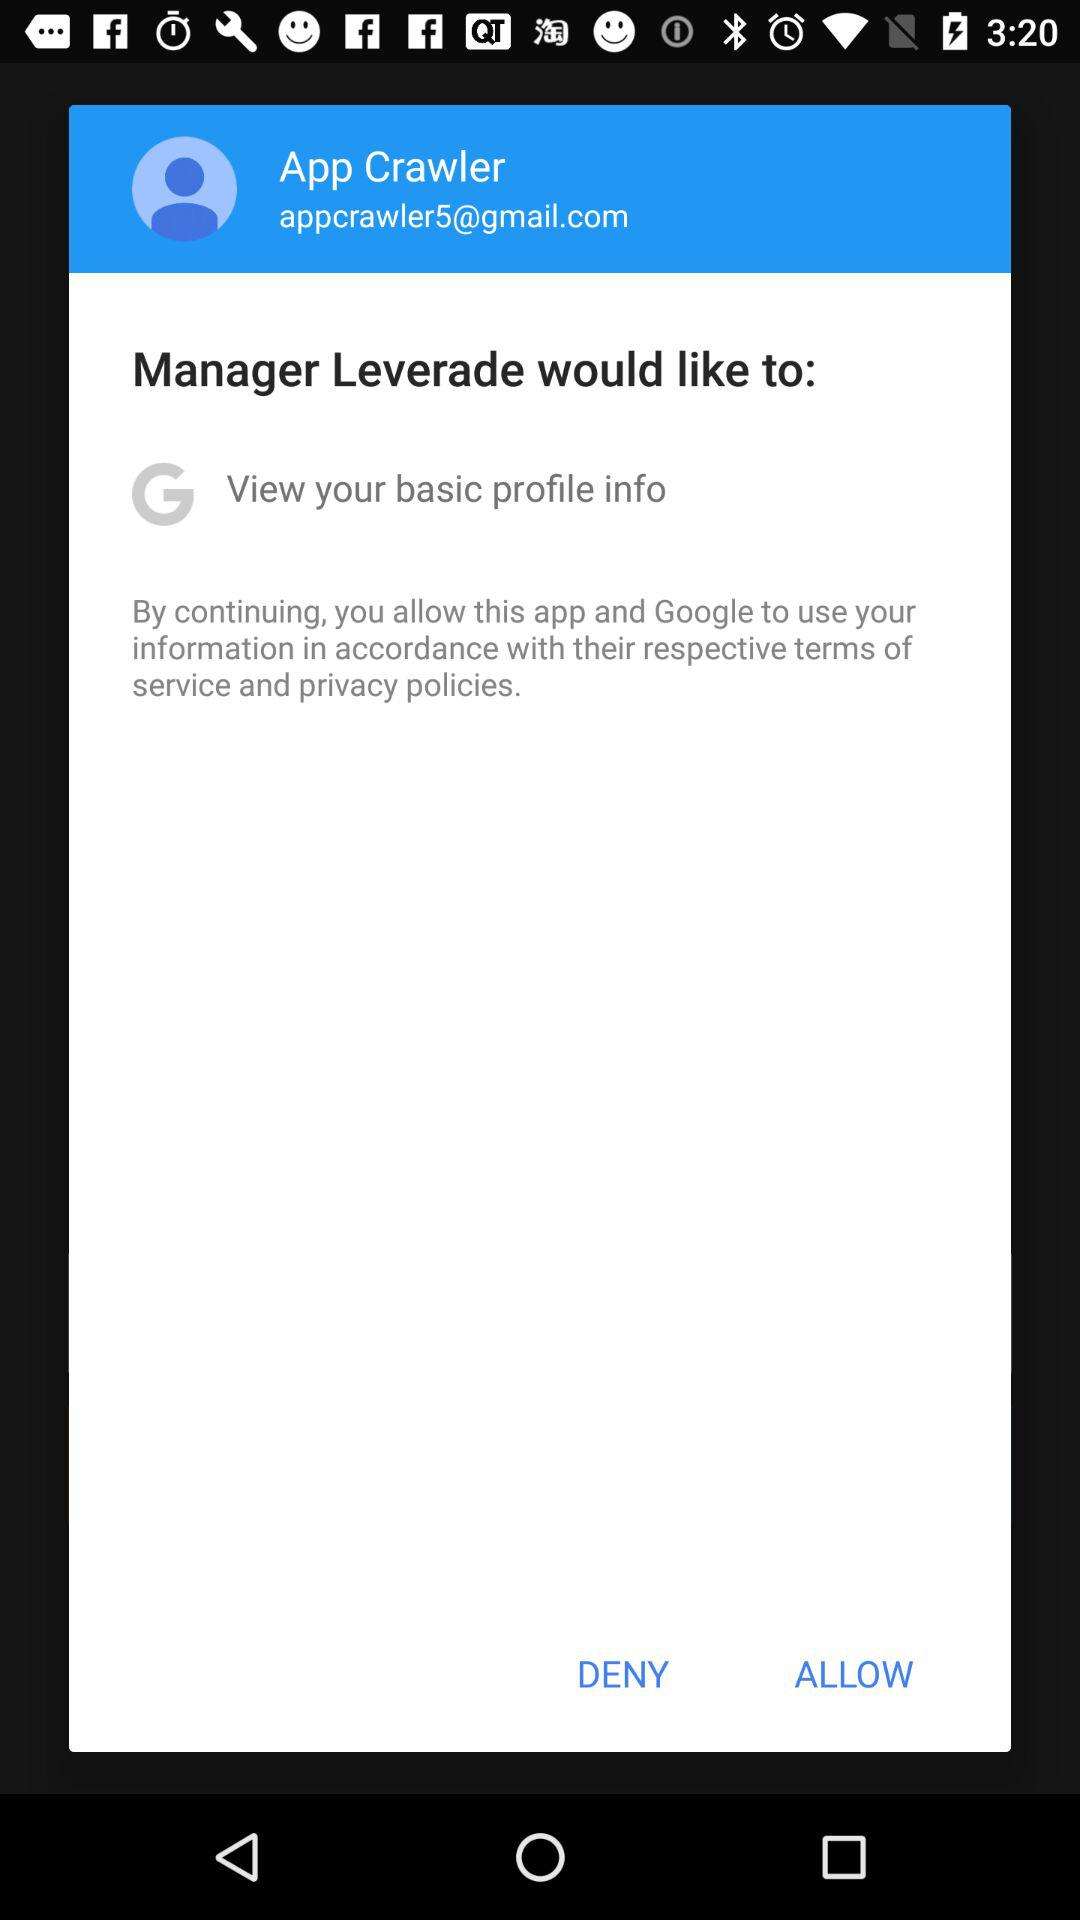What is the Gmail account? The Gmail account is appcrawler5@gmail.com. 